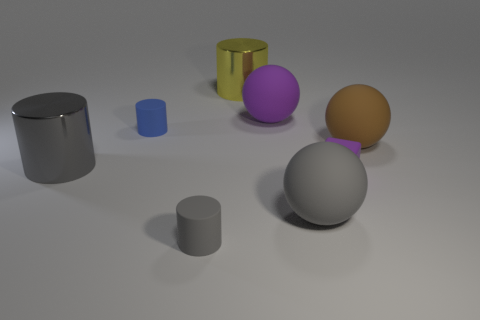Add 1 purple blocks. How many objects exist? 9 Subtract all cubes. How many objects are left? 7 Add 2 large green cylinders. How many large green cylinders exist? 2 Subtract 0 red cubes. How many objects are left? 8 Subtract all small rubber things. Subtract all shiny cylinders. How many objects are left? 3 Add 4 small blue rubber cylinders. How many small blue rubber cylinders are left? 5 